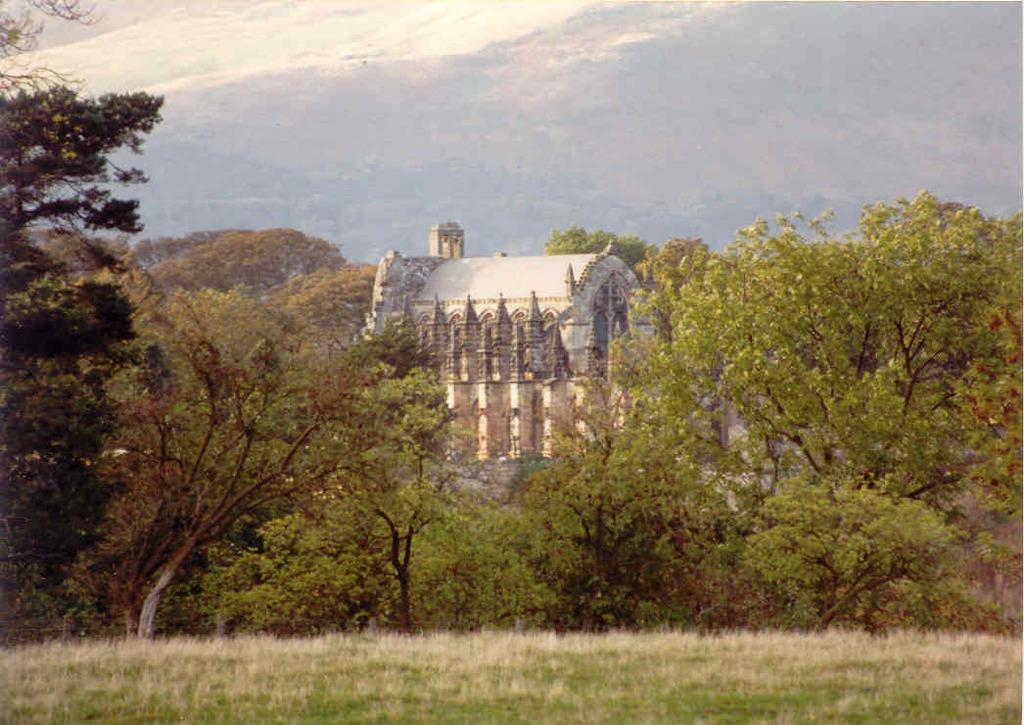What type of vegetation is present in the image? There are trees in the image. What type of structure can be seen in the image? There is a building in the image. What is the terrain like in the image? There is a hill in the image. What type of ground cover is visible in the image? There is grass on the ground in the image. Can you see the farmer working on the stage in the image? There is no farmer or stage present in the image. What color is the collar of the dog in the image? There is no dog or collar present in the image. 